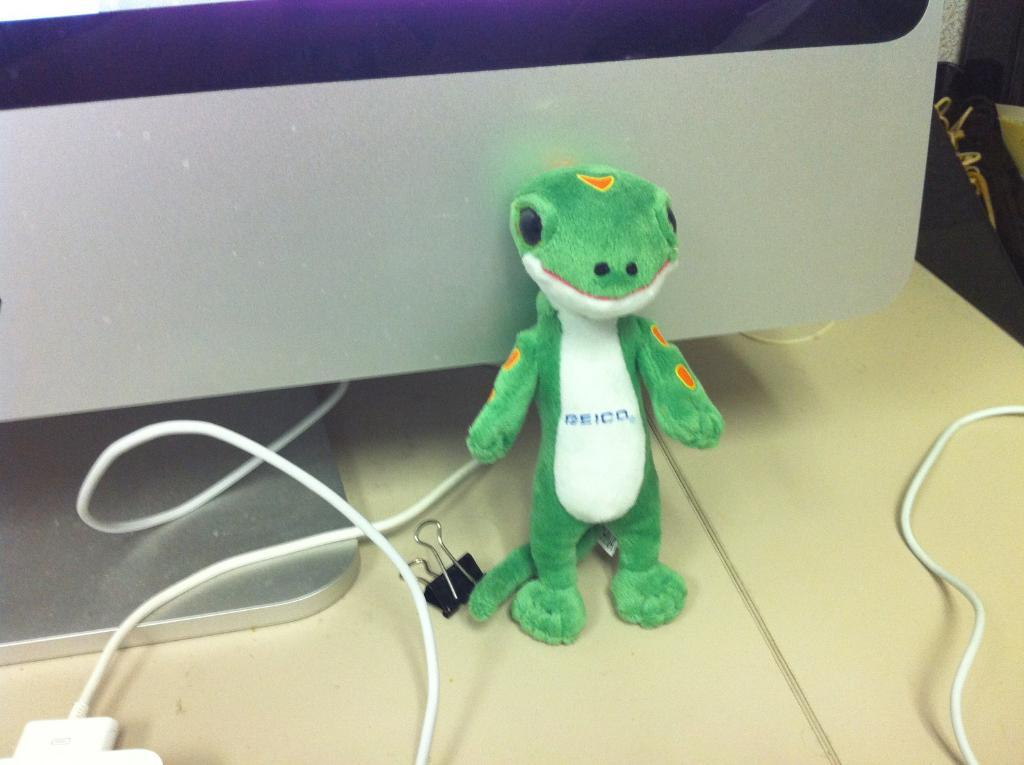What object can be seen on the surface in the image? There is a toy on a surface in the image. What else is present on the surface? There is a clip and wires on the surface. What can be seen in the background of the image? There is a monitor in the background. What type of soap is being used to clean the wrist in the image? There is no wrist or soap present in the image. 